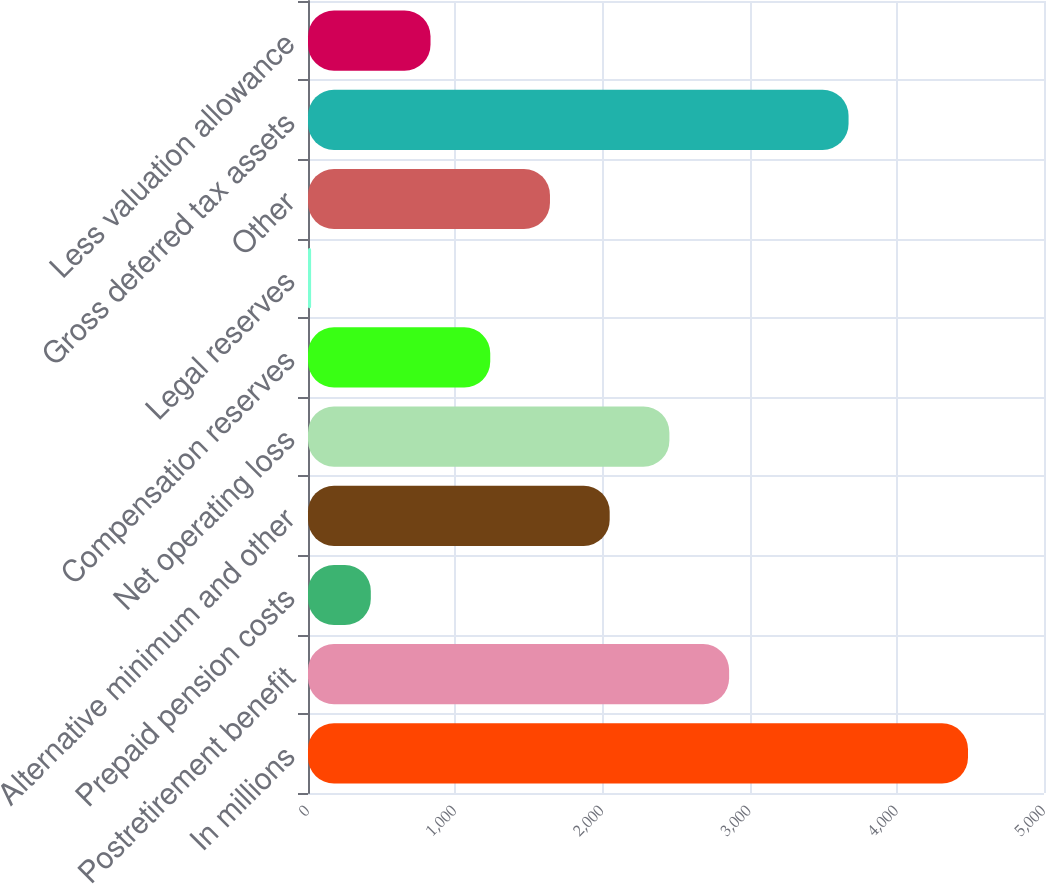Convert chart. <chart><loc_0><loc_0><loc_500><loc_500><bar_chart><fcel>In millions<fcel>Postretirement benefit<fcel>Prepaid pension costs<fcel>Alternative minimum and other<fcel>Net operating loss<fcel>Compensation reserves<fcel>Legal reserves<fcel>Other<fcel>Gross deferred tax assets<fcel>Less valuation allowance<nl><fcel>4483.7<fcel>2860.9<fcel>426.7<fcel>2049.5<fcel>2455.2<fcel>1238.1<fcel>21<fcel>1643.8<fcel>3672.3<fcel>832.4<nl></chart> 